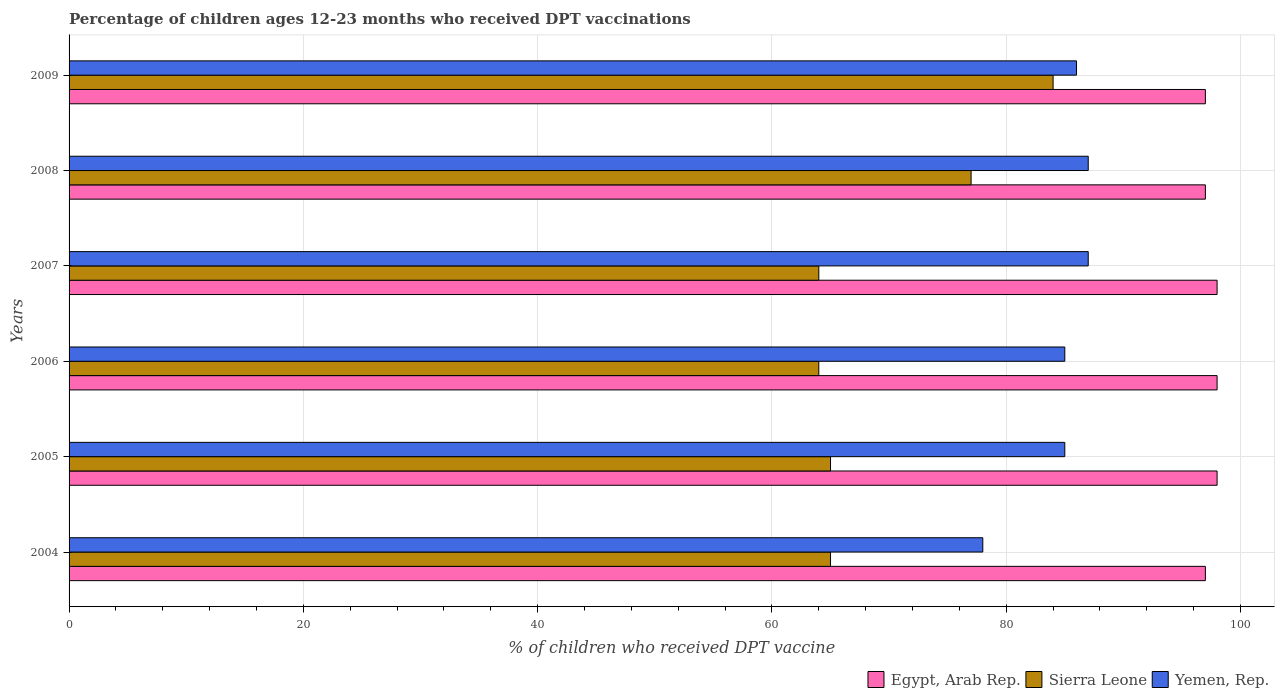Are the number of bars per tick equal to the number of legend labels?
Ensure brevity in your answer.  Yes. Are the number of bars on each tick of the Y-axis equal?
Your response must be concise. Yes. How many bars are there on the 5th tick from the top?
Give a very brief answer. 3. What is the label of the 2nd group of bars from the top?
Offer a terse response. 2008. In how many cases, is the number of bars for a given year not equal to the number of legend labels?
Your answer should be very brief. 0. What is the percentage of children who received DPT vaccination in Yemen, Rep. in 2009?
Offer a very short reply. 86. Across all years, what is the maximum percentage of children who received DPT vaccination in Yemen, Rep.?
Your answer should be compact. 87. Across all years, what is the minimum percentage of children who received DPT vaccination in Egypt, Arab Rep.?
Your answer should be compact. 97. In which year was the percentage of children who received DPT vaccination in Egypt, Arab Rep. minimum?
Your answer should be very brief. 2004. What is the total percentage of children who received DPT vaccination in Sierra Leone in the graph?
Keep it short and to the point. 419. What is the difference between the percentage of children who received DPT vaccination in Sierra Leone in 2004 and that in 2006?
Give a very brief answer. 1. What is the average percentage of children who received DPT vaccination in Yemen, Rep. per year?
Your answer should be compact. 84.67. In the year 2006, what is the difference between the percentage of children who received DPT vaccination in Egypt, Arab Rep. and percentage of children who received DPT vaccination in Yemen, Rep.?
Your answer should be compact. 13. What is the ratio of the percentage of children who received DPT vaccination in Yemen, Rep. in 2007 to that in 2009?
Offer a terse response. 1.01. Is the difference between the percentage of children who received DPT vaccination in Egypt, Arab Rep. in 2005 and 2009 greater than the difference between the percentage of children who received DPT vaccination in Yemen, Rep. in 2005 and 2009?
Offer a very short reply. Yes. What is the difference between the highest and the lowest percentage of children who received DPT vaccination in Sierra Leone?
Ensure brevity in your answer.  20. Is the sum of the percentage of children who received DPT vaccination in Egypt, Arab Rep. in 2004 and 2008 greater than the maximum percentage of children who received DPT vaccination in Sierra Leone across all years?
Make the answer very short. Yes. What does the 2nd bar from the top in 2005 represents?
Keep it short and to the point. Sierra Leone. What does the 1st bar from the bottom in 2008 represents?
Give a very brief answer. Egypt, Arab Rep. Are the values on the major ticks of X-axis written in scientific E-notation?
Ensure brevity in your answer.  No. How many legend labels are there?
Offer a terse response. 3. What is the title of the graph?
Provide a succinct answer. Percentage of children ages 12-23 months who received DPT vaccinations. What is the label or title of the X-axis?
Your answer should be very brief. % of children who received DPT vaccine. What is the % of children who received DPT vaccine in Egypt, Arab Rep. in 2004?
Offer a terse response. 97. What is the % of children who received DPT vaccine in Yemen, Rep. in 2004?
Ensure brevity in your answer.  78. What is the % of children who received DPT vaccine of Sierra Leone in 2006?
Your answer should be compact. 64. What is the % of children who received DPT vaccine of Egypt, Arab Rep. in 2007?
Offer a terse response. 98. What is the % of children who received DPT vaccine in Egypt, Arab Rep. in 2008?
Your answer should be very brief. 97. What is the % of children who received DPT vaccine of Yemen, Rep. in 2008?
Offer a terse response. 87. What is the % of children who received DPT vaccine in Egypt, Arab Rep. in 2009?
Make the answer very short. 97. What is the % of children who received DPT vaccine in Sierra Leone in 2009?
Provide a short and direct response. 84. What is the % of children who received DPT vaccine in Yemen, Rep. in 2009?
Provide a succinct answer. 86. Across all years, what is the maximum % of children who received DPT vaccine of Yemen, Rep.?
Provide a short and direct response. 87. Across all years, what is the minimum % of children who received DPT vaccine in Egypt, Arab Rep.?
Your response must be concise. 97. Across all years, what is the minimum % of children who received DPT vaccine of Sierra Leone?
Give a very brief answer. 64. What is the total % of children who received DPT vaccine of Egypt, Arab Rep. in the graph?
Provide a short and direct response. 585. What is the total % of children who received DPT vaccine of Sierra Leone in the graph?
Give a very brief answer. 419. What is the total % of children who received DPT vaccine in Yemen, Rep. in the graph?
Provide a short and direct response. 508. What is the difference between the % of children who received DPT vaccine of Egypt, Arab Rep. in 2004 and that in 2005?
Offer a very short reply. -1. What is the difference between the % of children who received DPT vaccine of Sierra Leone in 2004 and that in 2005?
Give a very brief answer. 0. What is the difference between the % of children who received DPT vaccine in Yemen, Rep. in 2004 and that in 2005?
Your response must be concise. -7. What is the difference between the % of children who received DPT vaccine in Egypt, Arab Rep. in 2004 and that in 2006?
Your response must be concise. -1. What is the difference between the % of children who received DPT vaccine in Egypt, Arab Rep. in 2004 and that in 2007?
Give a very brief answer. -1. What is the difference between the % of children who received DPT vaccine of Sierra Leone in 2004 and that in 2007?
Offer a very short reply. 1. What is the difference between the % of children who received DPT vaccine in Yemen, Rep. in 2004 and that in 2007?
Give a very brief answer. -9. What is the difference between the % of children who received DPT vaccine in Egypt, Arab Rep. in 2004 and that in 2008?
Offer a very short reply. 0. What is the difference between the % of children who received DPT vaccine of Yemen, Rep. in 2004 and that in 2008?
Your answer should be compact. -9. What is the difference between the % of children who received DPT vaccine of Egypt, Arab Rep. in 2004 and that in 2009?
Keep it short and to the point. 0. What is the difference between the % of children who received DPT vaccine of Egypt, Arab Rep. in 2005 and that in 2006?
Provide a short and direct response. 0. What is the difference between the % of children who received DPT vaccine of Yemen, Rep. in 2005 and that in 2006?
Your answer should be very brief. 0. What is the difference between the % of children who received DPT vaccine of Egypt, Arab Rep. in 2005 and that in 2007?
Offer a terse response. 0. What is the difference between the % of children who received DPT vaccine of Sierra Leone in 2005 and that in 2007?
Ensure brevity in your answer.  1. What is the difference between the % of children who received DPT vaccine of Sierra Leone in 2005 and that in 2008?
Your response must be concise. -12. What is the difference between the % of children who received DPT vaccine of Sierra Leone in 2006 and that in 2007?
Your answer should be very brief. 0. What is the difference between the % of children who received DPT vaccine in Yemen, Rep. in 2006 and that in 2007?
Offer a terse response. -2. What is the difference between the % of children who received DPT vaccine of Egypt, Arab Rep. in 2006 and that in 2008?
Your answer should be very brief. 1. What is the difference between the % of children who received DPT vaccine in Sierra Leone in 2006 and that in 2008?
Your answer should be very brief. -13. What is the difference between the % of children who received DPT vaccine in Egypt, Arab Rep. in 2006 and that in 2009?
Ensure brevity in your answer.  1. What is the difference between the % of children who received DPT vaccine in Sierra Leone in 2006 and that in 2009?
Your response must be concise. -20. What is the difference between the % of children who received DPT vaccine in Yemen, Rep. in 2006 and that in 2009?
Make the answer very short. -1. What is the difference between the % of children who received DPT vaccine of Egypt, Arab Rep. in 2007 and that in 2008?
Your answer should be compact. 1. What is the difference between the % of children who received DPT vaccine in Sierra Leone in 2007 and that in 2008?
Provide a succinct answer. -13. What is the difference between the % of children who received DPT vaccine in Yemen, Rep. in 2007 and that in 2008?
Ensure brevity in your answer.  0. What is the difference between the % of children who received DPT vaccine of Egypt, Arab Rep. in 2007 and that in 2009?
Your answer should be compact. 1. What is the difference between the % of children who received DPT vaccine in Sierra Leone in 2007 and that in 2009?
Provide a short and direct response. -20. What is the difference between the % of children who received DPT vaccine in Yemen, Rep. in 2007 and that in 2009?
Ensure brevity in your answer.  1. What is the difference between the % of children who received DPT vaccine in Egypt, Arab Rep. in 2004 and the % of children who received DPT vaccine in Sierra Leone in 2005?
Give a very brief answer. 32. What is the difference between the % of children who received DPT vaccine of Egypt, Arab Rep. in 2004 and the % of children who received DPT vaccine of Yemen, Rep. in 2005?
Your answer should be very brief. 12. What is the difference between the % of children who received DPT vaccine of Egypt, Arab Rep. in 2004 and the % of children who received DPT vaccine of Sierra Leone in 2006?
Keep it short and to the point. 33. What is the difference between the % of children who received DPT vaccine of Egypt, Arab Rep. in 2004 and the % of children who received DPT vaccine of Yemen, Rep. in 2006?
Provide a succinct answer. 12. What is the difference between the % of children who received DPT vaccine in Sierra Leone in 2004 and the % of children who received DPT vaccine in Yemen, Rep. in 2006?
Your answer should be very brief. -20. What is the difference between the % of children who received DPT vaccine of Egypt, Arab Rep. in 2004 and the % of children who received DPT vaccine of Sierra Leone in 2007?
Ensure brevity in your answer.  33. What is the difference between the % of children who received DPT vaccine in Egypt, Arab Rep. in 2004 and the % of children who received DPT vaccine in Sierra Leone in 2008?
Ensure brevity in your answer.  20. What is the difference between the % of children who received DPT vaccine in Sierra Leone in 2004 and the % of children who received DPT vaccine in Yemen, Rep. in 2008?
Make the answer very short. -22. What is the difference between the % of children who received DPT vaccine of Sierra Leone in 2004 and the % of children who received DPT vaccine of Yemen, Rep. in 2009?
Offer a very short reply. -21. What is the difference between the % of children who received DPT vaccine of Egypt, Arab Rep. in 2005 and the % of children who received DPT vaccine of Sierra Leone in 2006?
Ensure brevity in your answer.  34. What is the difference between the % of children who received DPT vaccine in Egypt, Arab Rep. in 2005 and the % of children who received DPT vaccine in Yemen, Rep. in 2006?
Your answer should be very brief. 13. What is the difference between the % of children who received DPT vaccine in Egypt, Arab Rep. in 2005 and the % of children who received DPT vaccine in Yemen, Rep. in 2007?
Ensure brevity in your answer.  11. What is the difference between the % of children who received DPT vaccine of Egypt, Arab Rep. in 2005 and the % of children who received DPT vaccine of Yemen, Rep. in 2008?
Your answer should be very brief. 11. What is the difference between the % of children who received DPT vaccine of Egypt, Arab Rep. in 2005 and the % of children who received DPT vaccine of Sierra Leone in 2009?
Your answer should be compact. 14. What is the difference between the % of children who received DPT vaccine in Sierra Leone in 2005 and the % of children who received DPT vaccine in Yemen, Rep. in 2009?
Offer a terse response. -21. What is the difference between the % of children who received DPT vaccine in Egypt, Arab Rep. in 2006 and the % of children who received DPT vaccine in Yemen, Rep. in 2007?
Provide a succinct answer. 11. What is the difference between the % of children who received DPT vaccine in Egypt, Arab Rep. in 2006 and the % of children who received DPT vaccine in Sierra Leone in 2008?
Your response must be concise. 21. What is the difference between the % of children who received DPT vaccine in Egypt, Arab Rep. in 2006 and the % of children who received DPT vaccine in Yemen, Rep. in 2008?
Ensure brevity in your answer.  11. What is the difference between the % of children who received DPT vaccine of Egypt, Arab Rep. in 2006 and the % of children who received DPT vaccine of Sierra Leone in 2009?
Give a very brief answer. 14. What is the difference between the % of children who received DPT vaccine of Egypt, Arab Rep. in 2006 and the % of children who received DPT vaccine of Yemen, Rep. in 2009?
Your answer should be very brief. 12. What is the difference between the % of children who received DPT vaccine of Sierra Leone in 2006 and the % of children who received DPT vaccine of Yemen, Rep. in 2009?
Your response must be concise. -22. What is the difference between the % of children who received DPT vaccine in Egypt, Arab Rep. in 2007 and the % of children who received DPT vaccine in Sierra Leone in 2008?
Offer a very short reply. 21. What is the difference between the % of children who received DPT vaccine of Egypt, Arab Rep. in 2007 and the % of children who received DPT vaccine of Yemen, Rep. in 2009?
Give a very brief answer. 12. What is the difference between the % of children who received DPT vaccine in Sierra Leone in 2007 and the % of children who received DPT vaccine in Yemen, Rep. in 2009?
Provide a short and direct response. -22. What is the difference between the % of children who received DPT vaccine in Egypt, Arab Rep. in 2008 and the % of children who received DPT vaccine in Sierra Leone in 2009?
Give a very brief answer. 13. What is the average % of children who received DPT vaccine in Egypt, Arab Rep. per year?
Give a very brief answer. 97.5. What is the average % of children who received DPT vaccine of Sierra Leone per year?
Make the answer very short. 69.83. What is the average % of children who received DPT vaccine of Yemen, Rep. per year?
Make the answer very short. 84.67. In the year 2004, what is the difference between the % of children who received DPT vaccine of Egypt, Arab Rep. and % of children who received DPT vaccine of Sierra Leone?
Ensure brevity in your answer.  32. In the year 2005, what is the difference between the % of children who received DPT vaccine in Egypt, Arab Rep. and % of children who received DPT vaccine in Sierra Leone?
Offer a very short reply. 33. In the year 2006, what is the difference between the % of children who received DPT vaccine in Sierra Leone and % of children who received DPT vaccine in Yemen, Rep.?
Your answer should be compact. -21. In the year 2007, what is the difference between the % of children who received DPT vaccine of Egypt, Arab Rep. and % of children who received DPT vaccine of Sierra Leone?
Give a very brief answer. 34. In the year 2007, what is the difference between the % of children who received DPT vaccine in Egypt, Arab Rep. and % of children who received DPT vaccine in Yemen, Rep.?
Keep it short and to the point. 11. In the year 2007, what is the difference between the % of children who received DPT vaccine of Sierra Leone and % of children who received DPT vaccine of Yemen, Rep.?
Make the answer very short. -23. In the year 2008, what is the difference between the % of children who received DPT vaccine of Sierra Leone and % of children who received DPT vaccine of Yemen, Rep.?
Offer a very short reply. -10. In the year 2009, what is the difference between the % of children who received DPT vaccine of Egypt, Arab Rep. and % of children who received DPT vaccine of Yemen, Rep.?
Give a very brief answer. 11. In the year 2009, what is the difference between the % of children who received DPT vaccine of Sierra Leone and % of children who received DPT vaccine of Yemen, Rep.?
Offer a terse response. -2. What is the ratio of the % of children who received DPT vaccine in Sierra Leone in 2004 to that in 2005?
Make the answer very short. 1. What is the ratio of the % of children who received DPT vaccine of Yemen, Rep. in 2004 to that in 2005?
Offer a terse response. 0.92. What is the ratio of the % of children who received DPT vaccine in Sierra Leone in 2004 to that in 2006?
Make the answer very short. 1.02. What is the ratio of the % of children who received DPT vaccine of Yemen, Rep. in 2004 to that in 2006?
Offer a terse response. 0.92. What is the ratio of the % of children who received DPT vaccine in Sierra Leone in 2004 to that in 2007?
Make the answer very short. 1.02. What is the ratio of the % of children who received DPT vaccine of Yemen, Rep. in 2004 to that in 2007?
Make the answer very short. 0.9. What is the ratio of the % of children who received DPT vaccine in Egypt, Arab Rep. in 2004 to that in 2008?
Offer a terse response. 1. What is the ratio of the % of children who received DPT vaccine in Sierra Leone in 2004 to that in 2008?
Make the answer very short. 0.84. What is the ratio of the % of children who received DPT vaccine in Yemen, Rep. in 2004 to that in 2008?
Provide a succinct answer. 0.9. What is the ratio of the % of children who received DPT vaccine of Sierra Leone in 2004 to that in 2009?
Your response must be concise. 0.77. What is the ratio of the % of children who received DPT vaccine in Yemen, Rep. in 2004 to that in 2009?
Offer a terse response. 0.91. What is the ratio of the % of children who received DPT vaccine in Egypt, Arab Rep. in 2005 to that in 2006?
Make the answer very short. 1. What is the ratio of the % of children who received DPT vaccine in Sierra Leone in 2005 to that in 2006?
Keep it short and to the point. 1.02. What is the ratio of the % of children who received DPT vaccine in Yemen, Rep. in 2005 to that in 2006?
Your answer should be very brief. 1. What is the ratio of the % of children who received DPT vaccine in Sierra Leone in 2005 to that in 2007?
Give a very brief answer. 1.02. What is the ratio of the % of children who received DPT vaccine of Yemen, Rep. in 2005 to that in 2007?
Make the answer very short. 0.98. What is the ratio of the % of children who received DPT vaccine of Egypt, Arab Rep. in 2005 to that in 2008?
Your response must be concise. 1.01. What is the ratio of the % of children who received DPT vaccine in Sierra Leone in 2005 to that in 2008?
Give a very brief answer. 0.84. What is the ratio of the % of children who received DPT vaccine in Yemen, Rep. in 2005 to that in 2008?
Ensure brevity in your answer.  0.98. What is the ratio of the % of children who received DPT vaccine of Egypt, Arab Rep. in 2005 to that in 2009?
Make the answer very short. 1.01. What is the ratio of the % of children who received DPT vaccine in Sierra Leone in 2005 to that in 2009?
Ensure brevity in your answer.  0.77. What is the ratio of the % of children who received DPT vaccine of Yemen, Rep. in 2005 to that in 2009?
Your answer should be very brief. 0.99. What is the ratio of the % of children who received DPT vaccine of Egypt, Arab Rep. in 2006 to that in 2007?
Keep it short and to the point. 1. What is the ratio of the % of children who received DPT vaccine of Yemen, Rep. in 2006 to that in 2007?
Your response must be concise. 0.98. What is the ratio of the % of children who received DPT vaccine of Egypt, Arab Rep. in 2006 to that in 2008?
Offer a terse response. 1.01. What is the ratio of the % of children who received DPT vaccine of Sierra Leone in 2006 to that in 2008?
Provide a succinct answer. 0.83. What is the ratio of the % of children who received DPT vaccine in Egypt, Arab Rep. in 2006 to that in 2009?
Your answer should be very brief. 1.01. What is the ratio of the % of children who received DPT vaccine of Sierra Leone in 2006 to that in 2009?
Your answer should be compact. 0.76. What is the ratio of the % of children who received DPT vaccine in Yemen, Rep. in 2006 to that in 2009?
Ensure brevity in your answer.  0.99. What is the ratio of the % of children who received DPT vaccine in Egypt, Arab Rep. in 2007 to that in 2008?
Give a very brief answer. 1.01. What is the ratio of the % of children who received DPT vaccine in Sierra Leone in 2007 to that in 2008?
Offer a very short reply. 0.83. What is the ratio of the % of children who received DPT vaccine in Yemen, Rep. in 2007 to that in 2008?
Offer a very short reply. 1. What is the ratio of the % of children who received DPT vaccine of Egypt, Arab Rep. in 2007 to that in 2009?
Give a very brief answer. 1.01. What is the ratio of the % of children who received DPT vaccine of Sierra Leone in 2007 to that in 2009?
Your answer should be very brief. 0.76. What is the ratio of the % of children who received DPT vaccine in Yemen, Rep. in 2007 to that in 2009?
Provide a short and direct response. 1.01. What is the ratio of the % of children who received DPT vaccine in Yemen, Rep. in 2008 to that in 2009?
Provide a succinct answer. 1.01. What is the difference between the highest and the second highest % of children who received DPT vaccine of Yemen, Rep.?
Your answer should be very brief. 0. What is the difference between the highest and the lowest % of children who received DPT vaccine in Sierra Leone?
Your answer should be very brief. 20. What is the difference between the highest and the lowest % of children who received DPT vaccine of Yemen, Rep.?
Keep it short and to the point. 9. 